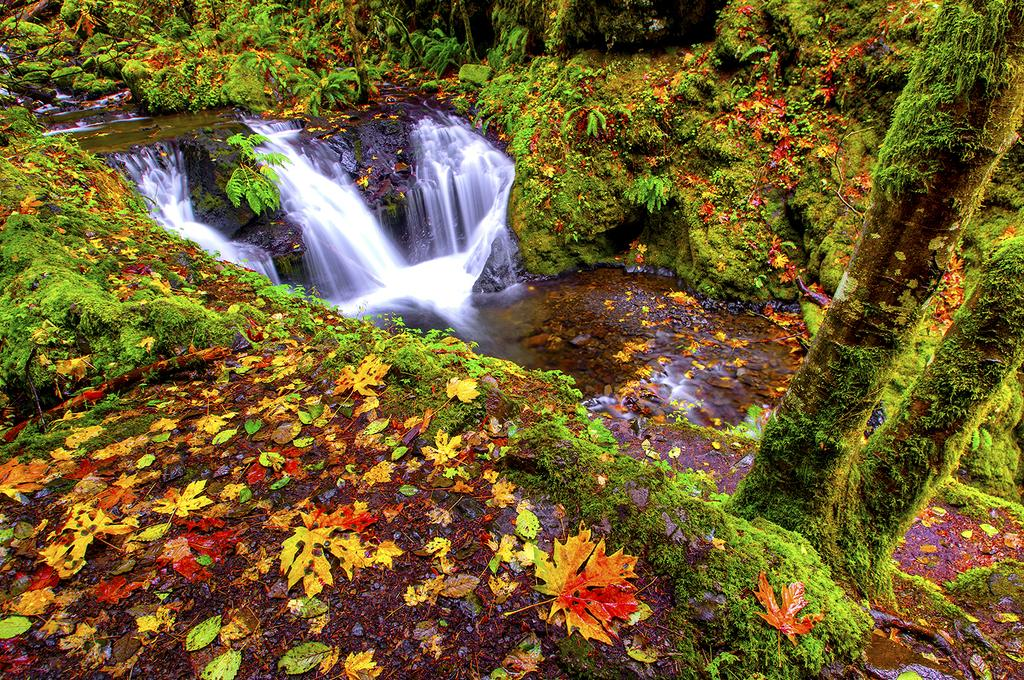What type of vegetation can be seen in the image? There are plants and trees in the image. What colors can be observed on the trees in the image? The trees have different colors, including yellow, red, and green. What is visible in the background of the image? The background includes waterfalls and stones. What type of potato is being played by the band in the image? There is no potato or band present in the image. What is the cause of death for the person in the image? There is no person or indication of death in the image. 